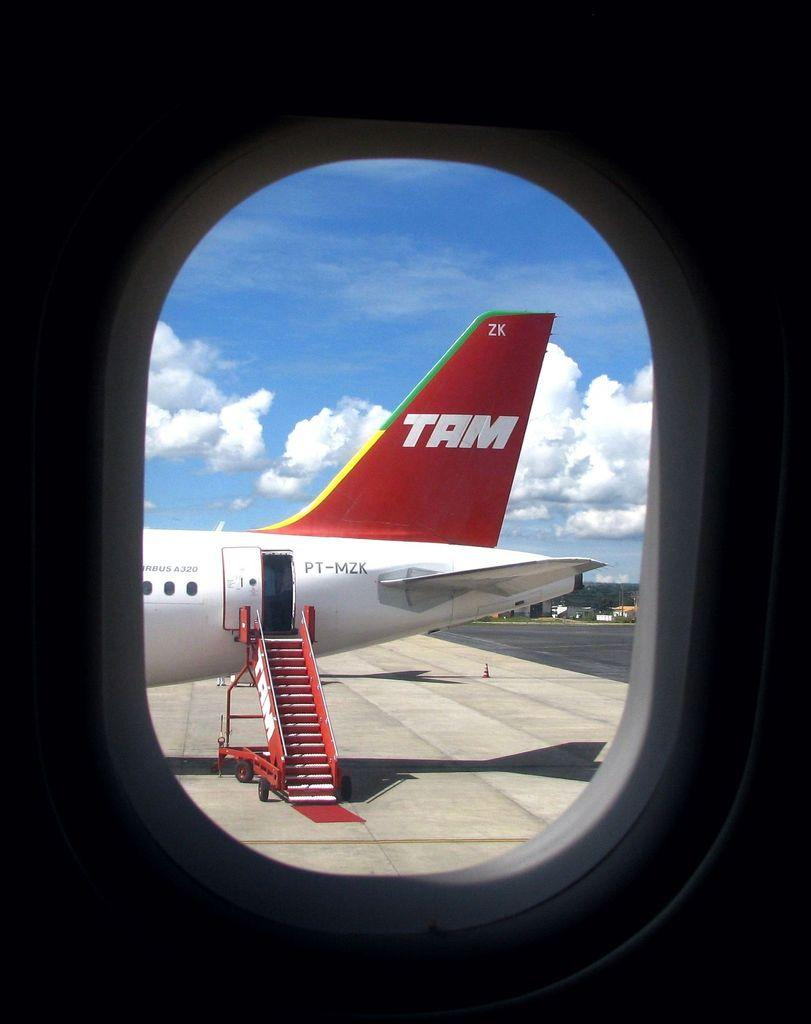What is the main subject of the image? The main subject of the image is an aeroplane. What feature can be seen on the aeroplane? The aeroplane has a window. What can be seen through the window of the aeroplane? Another aeroplane is visible through the window. What is visible in the background of the image? Buildings and the sky are visible in the background of the image. What is the condition of the sky in the image? Clouds are present in the sky. How far away is the alley from the aeroplane in the image? There is no alley present in the image, so it cannot be determined how far away it might be from the aeroplane. 